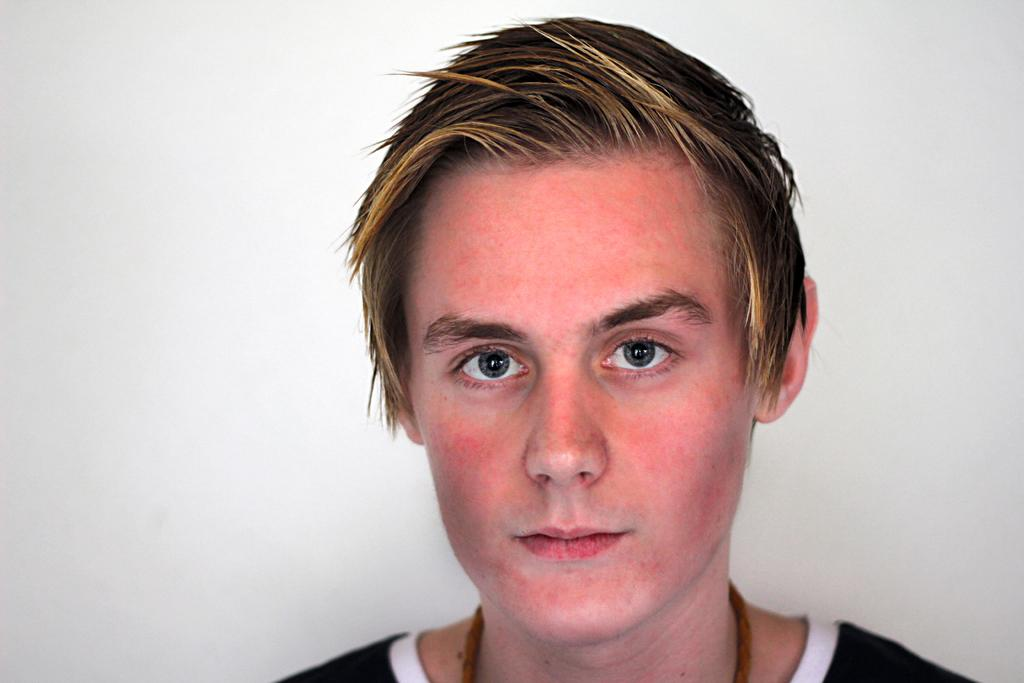What is the main subject of the image? There is a person in the image. What is the color of the background in the image? The background of the image is white. How many chairs are placed around the lake in the image? There is no lake or chairs present in the image; it only features a person and a white background. 